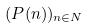Convert formula to latex. <formula><loc_0><loc_0><loc_500><loc_500>( P ( n ) ) _ { n \in N }</formula> 